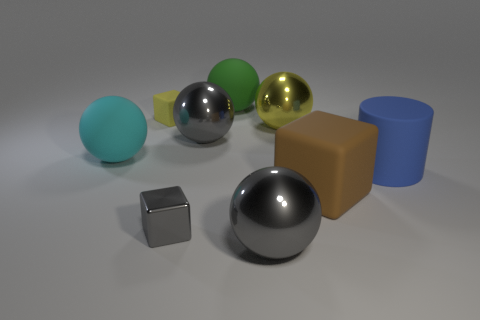Subtract 2 spheres. How many spheres are left? 3 Subtract all green spheres. How many spheres are left? 4 Subtract all yellow spheres. How many spheres are left? 4 Subtract all cubes. How many objects are left? 6 Subtract all red blocks. Subtract all gray cylinders. How many blocks are left? 3 Add 4 metal balls. How many metal balls exist? 7 Subtract 1 gray cubes. How many objects are left? 8 Subtract all large yellow balls. Subtract all tiny gray metallic objects. How many objects are left? 7 Add 7 large green spheres. How many large green spheres are left? 8 